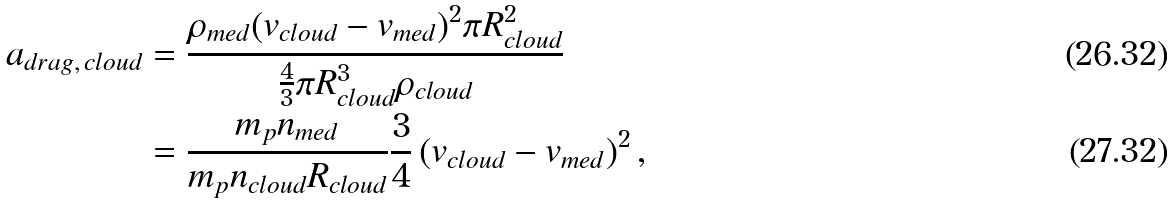Convert formula to latex. <formula><loc_0><loc_0><loc_500><loc_500>a _ { d r a g , \, c l o u d } & = \frac { \rho _ { m e d } ( v _ { c l o u d } - v _ { m e d } ) ^ { 2 } \pi R ^ { 2 } _ { c l o u d } } { \frac { 4 } { 3 } \pi R ^ { 3 } _ { c l o u d } \rho _ { c l o u d } } \\ & = \frac { m _ { p } n _ { m e d } } { m _ { p } n _ { c l o u d } R _ { c l o u d } } \frac { 3 } { 4 } \left ( v _ { c l o u d } - v _ { m e d } \right ) ^ { 2 } ,</formula> 